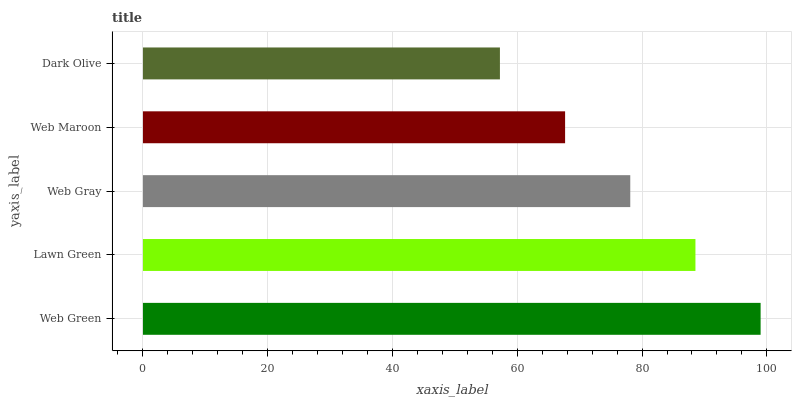Is Dark Olive the minimum?
Answer yes or no. Yes. Is Web Green the maximum?
Answer yes or no. Yes. Is Lawn Green the minimum?
Answer yes or no. No. Is Lawn Green the maximum?
Answer yes or no. No. Is Web Green greater than Lawn Green?
Answer yes or no. Yes. Is Lawn Green less than Web Green?
Answer yes or no. Yes. Is Lawn Green greater than Web Green?
Answer yes or no. No. Is Web Green less than Lawn Green?
Answer yes or no. No. Is Web Gray the high median?
Answer yes or no. Yes. Is Web Gray the low median?
Answer yes or no. Yes. Is Web Maroon the high median?
Answer yes or no. No. Is Web Green the low median?
Answer yes or no. No. 